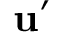Convert formula to latex. <formula><loc_0><loc_0><loc_500><loc_500>u ^ { \prime }</formula> 